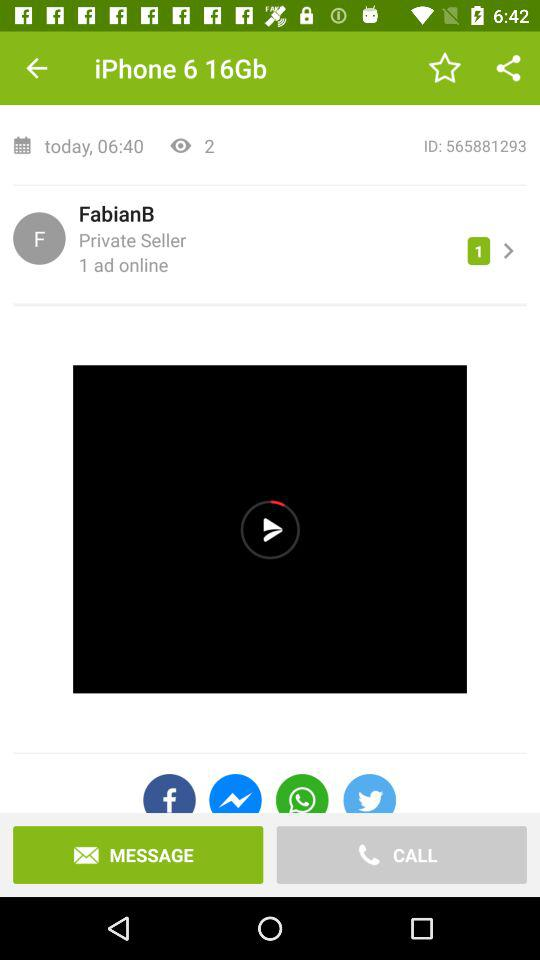How many ads are available online for this item?
Answer the question using a single word or phrase. 1 